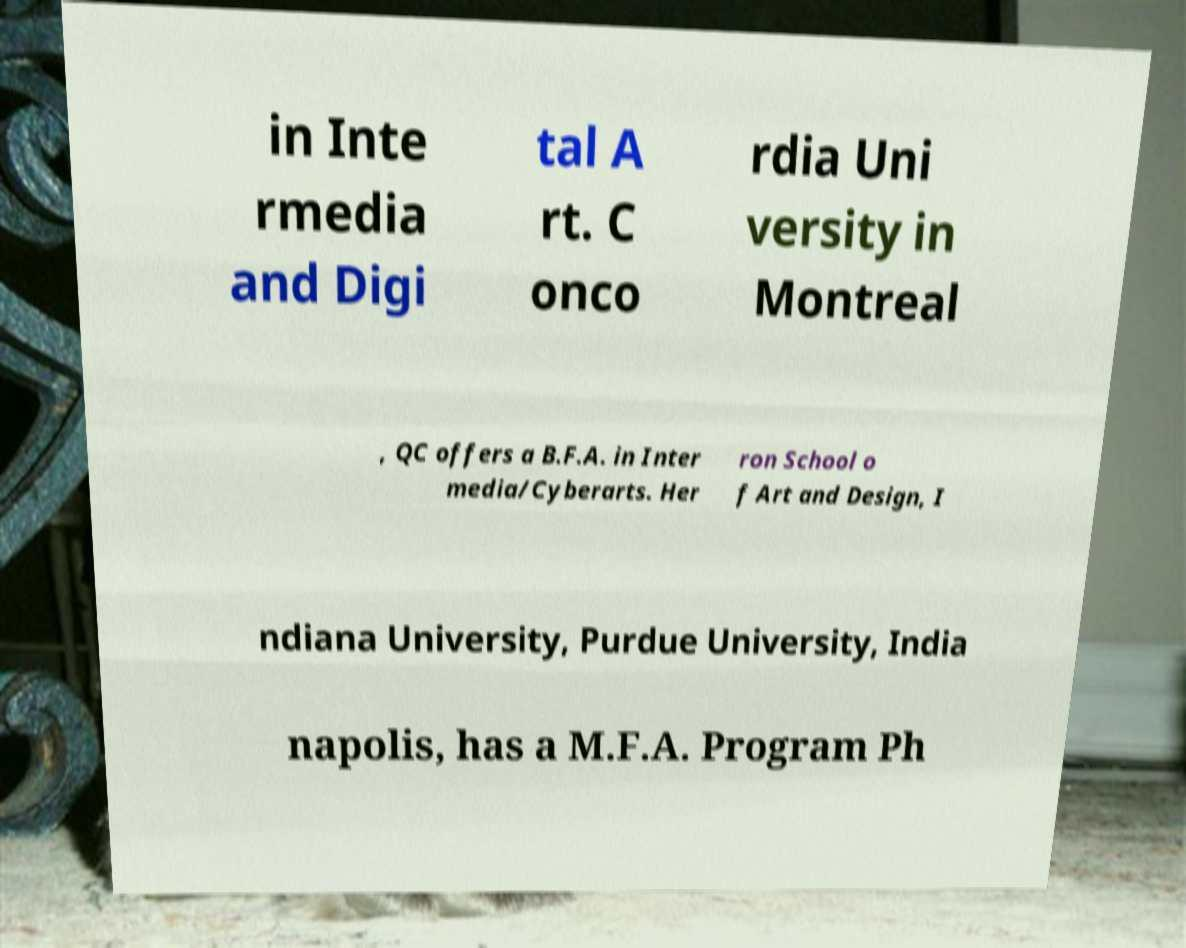There's text embedded in this image that I need extracted. Can you transcribe it verbatim? in Inte rmedia and Digi tal A rt. C onco rdia Uni versity in Montreal , QC offers a B.F.A. in Inter media/Cyberarts. Her ron School o f Art and Design, I ndiana University, Purdue University, India napolis, has a M.F.A. Program Ph 